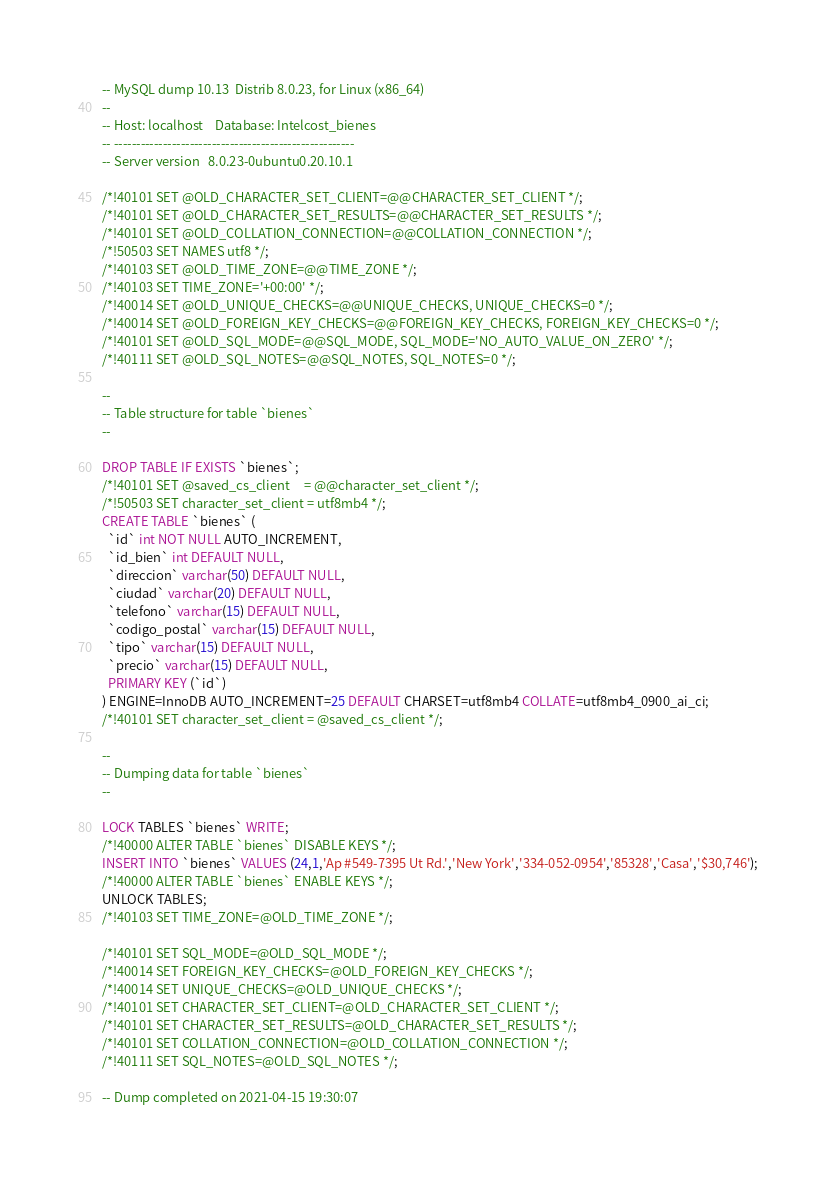Convert code to text. <code><loc_0><loc_0><loc_500><loc_500><_SQL_>-- MySQL dump 10.13  Distrib 8.0.23, for Linux (x86_64)
--
-- Host: localhost    Database: Intelcost_bienes
-- ------------------------------------------------------
-- Server version	8.0.23-0ubuntu0.20.10.1

/*!40101 SET @OLD_CHARACTER_SET_CLIENT=@@CHARACTER_SET_CLIENT */;
/*!40101 SET @OLD_CHARACTER_SET_RESULTS=@@CHARACTER_SET_RESULTS */;
/*!40101 SET @OLD_COLLATION_CONNECTION=@@COLLATION_CONNECTION */;
/*!50503 SET NAMES utf8 */;
/*!40103 SET @OLD_TIME_ZONE=@@TIME_ZONE */;
/*!40103 SET TIME_ZONE='+00:00' */;
/*!40014 SET @OLD_UNIQUE_CHECKS=@@UNIQUE_CHECKS, UNIQUE_CHECKS=0 */;
/*!40014 SET @OLD_FOREIGN_KEY_CHECKS=@@FOREIGN_KEY_CHECKS, FOREIGN_KEY_CHECKS=0 */;
/*!40101 SET @OLD_SQL_MODE=@@SQL_MODE, SQL_MODE='NO_AUTO_VALUE_ON_ZERO' */;
/*!40111 SET @OLD_SQL_NOTES=@@SQL_NOTES, SQL_NOTES=0 */;

--
-- Table structure for table `bienes`
--

DROP TABLE IF EXISTS `bienes`;
/*!40101 SET @saved_cs_client     = @@character_set_client */;
/*!50503 SET character_set_client = utf8mb4 */;
CREATE TABLE `bienes` (
  `id` int NOT NULL AUTO_INCREMENT,
  `id_bien` int DEFAULT NULL,
  `direccion` varchar(50) DEFAULT NULL,
  `ciudad` varchar(20) DEFAULT NULL,
  `telefono` varchar(15) DEFAULT NULL,
  `codigo_postal` varchar(15) DEFAULT NULL,
  `tipo` varchar(15) DEFAULT NULL,
  `precio` varchar(15) DEFAULT NULL,
  PRIMARY KEY (`id`)
) ENGINE=InnoDB AUTO_INCREMENT=25 DEFAULT CHARSET=utf8mb4 COLLATE=utf8mb4_0900_ai_ci;
/*!40101 SET character_set_client = @saved_cs_client */;

--
-- Dumping data for table `bienes`
--

LOCK TABLES `bienes` WRITE;
/*!40000 ALTER TABLE `bienes` DISABLE KEYS */;
INSERT INTO `bienes` VALUES (24,1,'Ap #549-7395 Ut Rd.','New York','334-052-0954','85328','Casa','$30,746');
/*!40000 ALTER TABLE `bienes` ENABLE KEYS */;
UNLOCK TABLES;
/*!40103 SET TIME_ZONE=@OLD_TIME_ZONE */;

/*!40101 SET SQL_MODE=@OLD_SQL_MODE */;
/*!40014 SET FOREIGN_KEY_CHECKS=@OLD_FOREIGN_KEY_CHECKS */;
/*!40014 SET UNIQUE_CHECKS=@OLD_UNIQUE_CHECKS */;
/*!40101 SET CHARACTER_SET_CLIENT=@OLD_CHARACTER_SET_CLIENT */;
/*!40101 SET CHARACTER_SET_RESULTS=@OLD_CHARACTER_SET_RESULTS */;
/*!40101 SET COLLATION_CONNECTION=@OLD_COLLATION_CONNECTION */;
/*!40111 SET SQL_NOTES=@OLD_SQL_NOTES */;

-- Dump completed on 2021-04-15 19:30:07
</code> 